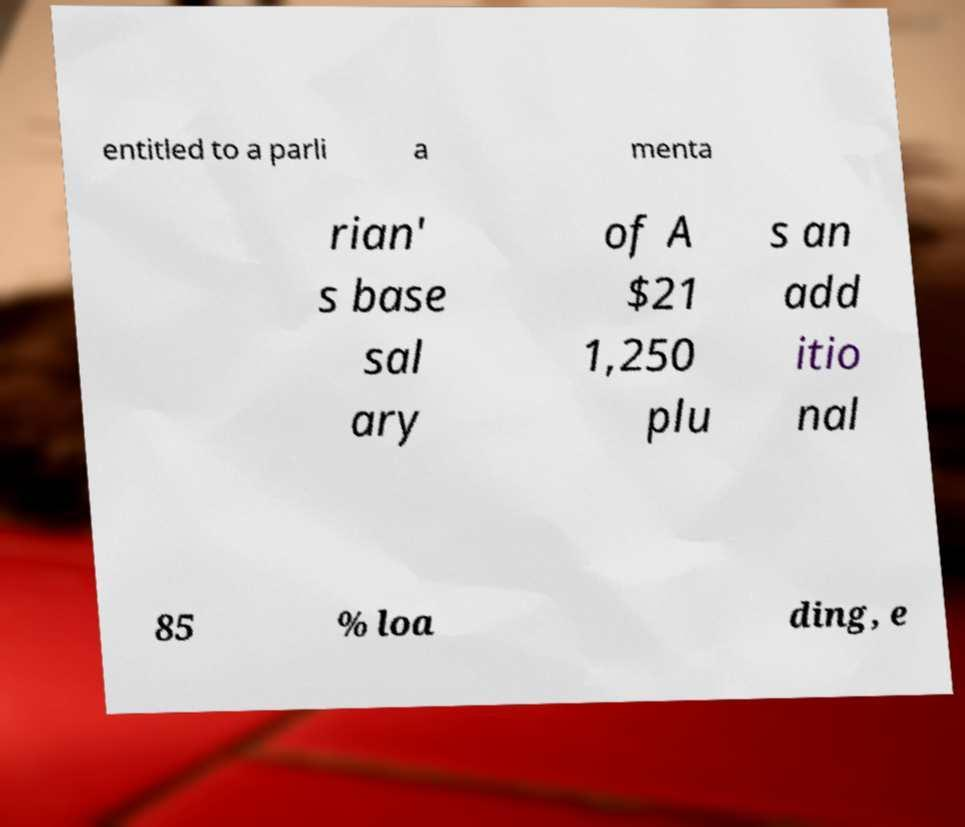Can you accurately transcribe the text from the provided image for me? entitled to a parli a menta rian' s base sal ary of A $21 1,250 plu s an add itio nal 85 % loa ding, e 